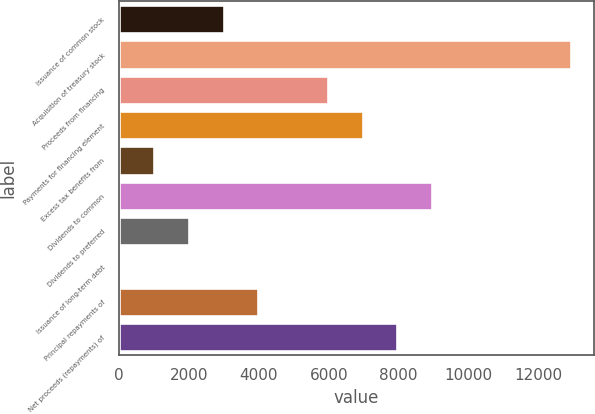<chart> <loc_0><loc_0><loc_500><loc_500><bar_chart><fcel>Issuance of common stock<fcel>Acquisition of treasury stock<fcel>Proceeds from financing<fcel>Payments for financing element<fcel>Excess tax benefits from<fcel>Dividends to common<fcel>Dividends to preferred<fcel>Issuance of long-term debt<fcel>Principal repayments of<fcel>Net proceeds (repayments) of<nl><fcel>2987.81<fcel>12946.5<fcel>5975.42<fcel>6971.29<fcel>996.07<fcel>8963.03<fcel>1991.94<fcel>0.2<fcel>3983.68<fcel>7967.16<nl></chart> 